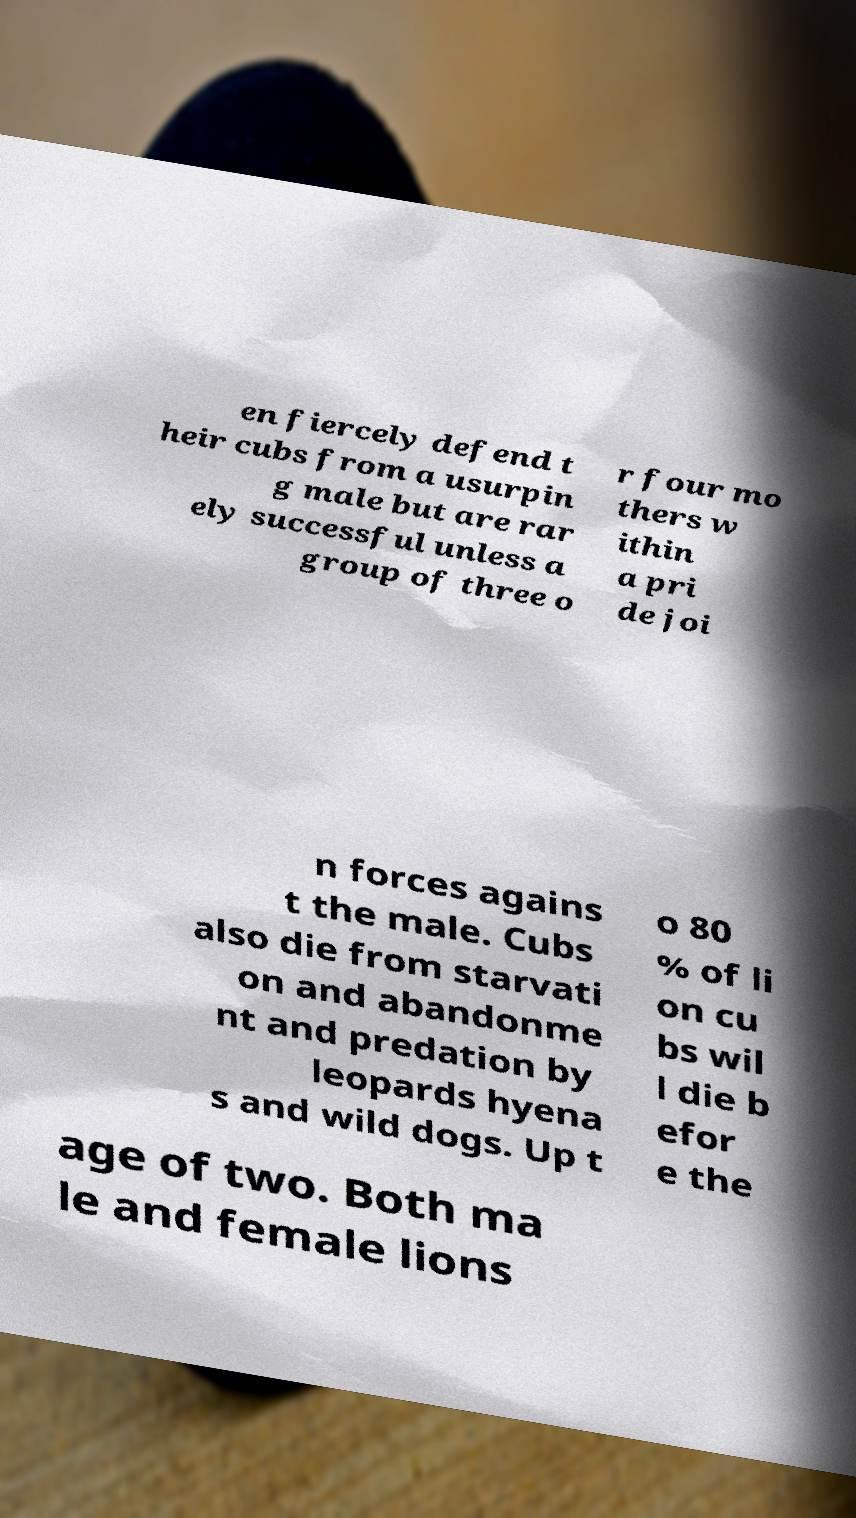Can you read and provide the text displayed in the image?This photo seems to have some interesting text. Can you extract and type it out for me? en fiercely defend t heir cubs from a usurpin g male but are rar ely successful unless a group of three o r four mo thers w ithin a pri de joi n forces agains t the male. Cubs also die from starvati on and abandonme nt and predation by leopards hyena s and wild dogs. Up t o 80 % of li on cu bs wil l die b efor e the age of two. Both ma le and female lions 